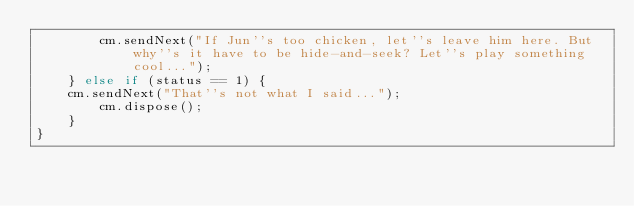Convert code to text. <code><loc_0><loc_0><loc_500><loc_500><_JavaScript_>    	cm.sendNext("If Jun''s too chicken, let''s leave him here. But why''s it have to be hide-and-seek? Let''s play something cool...");
    } else if (status == 1) {
	cm.sendNext("That''s not what I said...");
    	cm.dispose();
    }
}</code> 